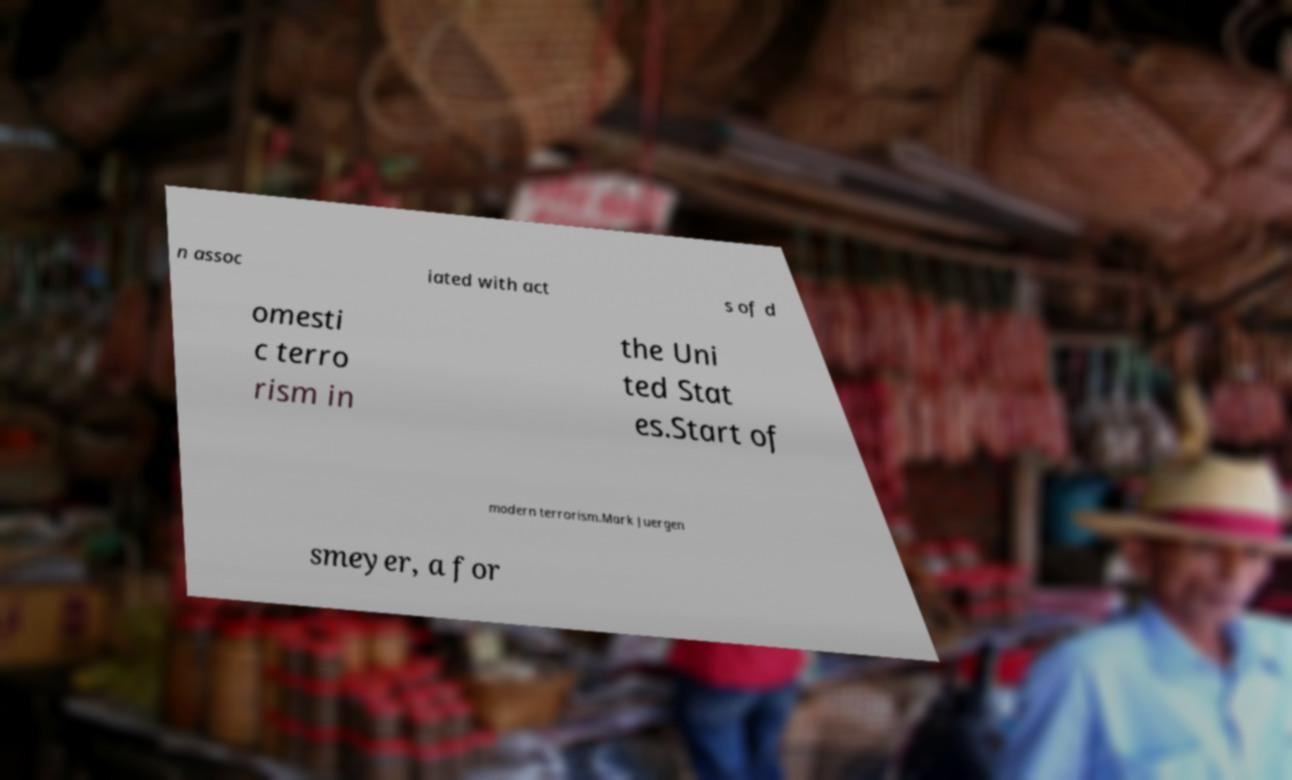Can you read and provide the text displayed in the image?This photo seems to have some interesting text. Can you extract and type it out for me? n assoc iated with act s of d omesti c terro rism in the Uni ted Stat es.Start of modern terrorism.Mark Juergen smeyer, a for 